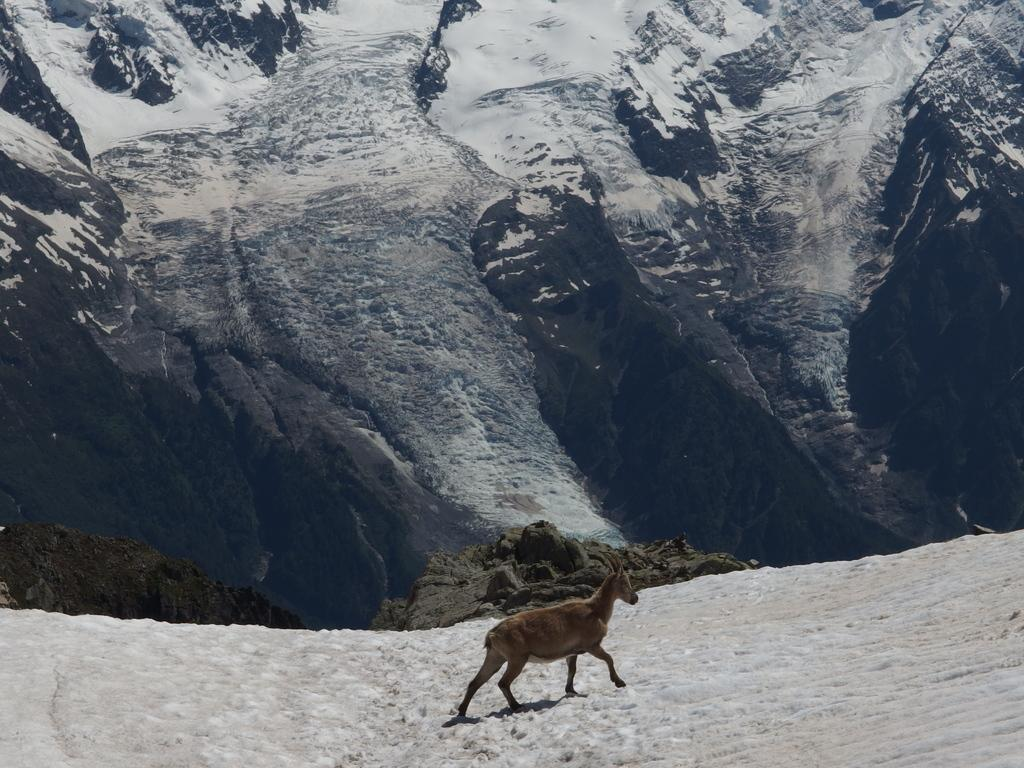What type of animal can be seen in the image? There is an animal in the image, but its specific type cannot be determined from the provided facts. Where is the animal located in the image? The animal is on the snow in the image. What can be seen in the background of the image? There are mountains in the background of the image. How are the mountains affected by the weather? The mountains are covered by snow, indicating that it is likely cold or snowy. What type of good-bye message is written on the alley wall in the image? There is no alley or good-bye message present in the image; it features an animal on the snow with mountains in the background. 